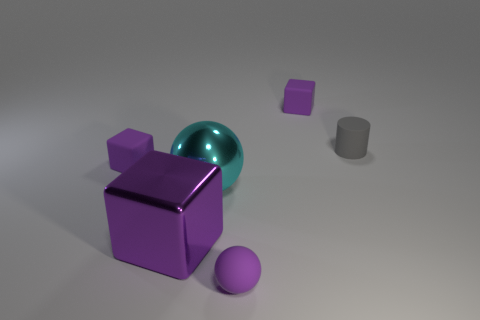Subtract all red cylinders. Subtract all brown balls. How many cylinders are left? 1 Add 4 tiny gray matte cylinders. How many objects exist? 10 Subtract all spheres. How many objects are left? 4 Subtract all tiny purple balls. Subtract all spheres. How many objects are left? 3 Add 5 tiny rubber cubes. How many tiny rubber cubes are left? 7 Add 3 yellow cylinders. How many yellow cylinders exist? 3 Subtract 0 red spheres. How many objects are left? 6 